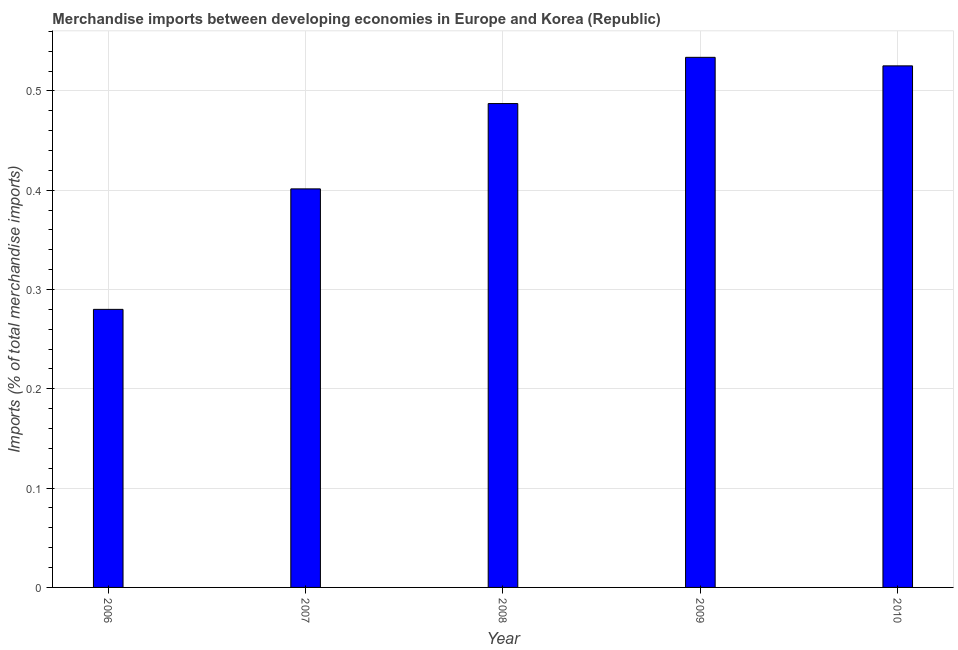Does the graph contain grids?
Offer a terse response. Yes. What is the title of the graph?
Your answer should be very brief. Merchandise imports between developing economies in Europe and Korea (Republic). What is the label or title of the Y-axis?
Provide a succinct answer. Imports (% of total merchandise imports). What is the merchandise imports in 2009?
Keep it short and to the point. 0.53. Across all years, what is the maximum merchandise imports?
Ensure brevity in your answer.  0.53. Across all years, what is the minimum merchandise imports?
Your answer should be very brief. 0.28. In which year was the merchandise imports minimum?
Your answer should be very brief. 2006. What is the sum of the merchandise imports?
Provide a succinct answer. 2.23. What is the difference between the merchandise imports in 2006 and 2009?
Give a very brief answer. -0.25. What is the average merchandise imports per year?
Keep it short and to the point. 0.45. What is the median merchandise imports?
Provide a short and direct response. 0.49. In how many years, is the merchandise imports greater than 0.1 %?
Keep it short and to the point. 5. Do a majority of the years between 2006 and 2010 (inclusive) have merchandise imports greater than 0.1 %?
Offer a very short reply. Yes. What is the ratio of the merchandise imports in 2007 to that in 2009?
Your answer should be very brief. 0.75. Is the merchandise imports in 2006 less than that in 2008?
Offer a very short reply. Yes. Is the difference between the merchandise imports in 2007 and 2009 greater than the difference between any two years?
Your answer should be compact. No. What is the difference between the highest and the second highest merchandise imports?
Your answer should be very brief. 0.01. In how many years, is the merchandise imports greater than the average merchandise imports taken over all years?
Offer a terse response. 3. Are all the bars in the graph horizontal?
Give a very brief answer. No. What is the difference between two consecutive major ticks on the Y-axis?
Give a very brief answer. 0.1. What is the Imports (% of total merchandise imports) of 2006?
Keep it short and to the point. 0.28. What is the Imports (% of total merchandise imports) in 2007?
Your response must be concise. 0.4. What is the Imports (% of total merchandise imports) in 2008?
Offer a terse response. 0.49. What is the Imports (% of total merchandise imports) of 2009?
Your response must be concise. 0.53. What is the Imports (% of total merchandise imports) in 2010?
Your answer should be very brief. 0.53. What is the difference between the Imports (% of total merchandise imports) in 2006 and 2007?
Offer a terse response. -0.12. What is the difference between the Imports (% of total merchandise imports) in 2006 and 2008?
Your answer should be compact. -0.21. What is the difference between the Imports (% of total merchandise imports) in 2006 and 2009?
Your response must be concise. -0.25. What is the difference between the Imports (% of total merchandise imports) in 2006 and 2010?
Your answer should be compact. -0.25. What is the difference between the Imports (% of total merchandise imports) in 2007 and 2008?
Provide a short and direct response. -0.09. What is the difference between the Imports (% of total merchandise imports) in 2007 and 2009?
Ensure brevity in your answer.  -0.13. What is the difference between the Imports (% of total merchandise imports) in 2007 and 2010?
Keep it short and to the point. -0.12. What is the difference between the Imports (% of total merchandise imports) in 2008 and 2009?
Give a very brief answer. -0.05. What is the difference between the Imports (% of total merchandise imports) in 2008 and 2010?
Your answer should be very brief. -0.04. What is the difference between the Imports (% of total merchandise imports) in 2009 and 2010?
Keep it short and to the point. 0.01. What is the ratio of the Imports (% of total merchandise imports) in 2006 to that in 2007?
Provide a succinct answer. 0.7. What is the ratio of the Imports (% of total merchandise imports) in 2006 to that in 2008?
Provide a succinct answer. 0.57. What is the ratio of the Imports (% of total merchandise imports) in 2006 to that in 2009?
Your answer should be compact. 0.53. What is the ratio of the Imports (% of total merchandise imports) in 2006 to that in 2010?
Provide a short and direct response. 0.53. What is the ratio of the Imports (% of total merchandise imports) in 2007 to that in 2008?
Your response must be concise. 0.82. What is the ratio of the Imports (% of total merchandise imports) in 2007 to that in 2009?
Offer a terse response. 0.75. What is the ratio of the Imports (% of total merchandise imports) in 2007 to that in 2010?
Make the answer very short. 0.76. What is the ratio of the Imports (% of total merchandise imports) in 2008 to that in 2009?
Make the answer very short. 0.91. What is the ratio of the Imports (% of total merchandise imports) in 2008 to that in 2010?
Provide a short and direct response. 0.93. What is the ratio of the Imports (% of total merchandise imports) in 2009 to that in 2010?
Your response must be concise. 1.02. 